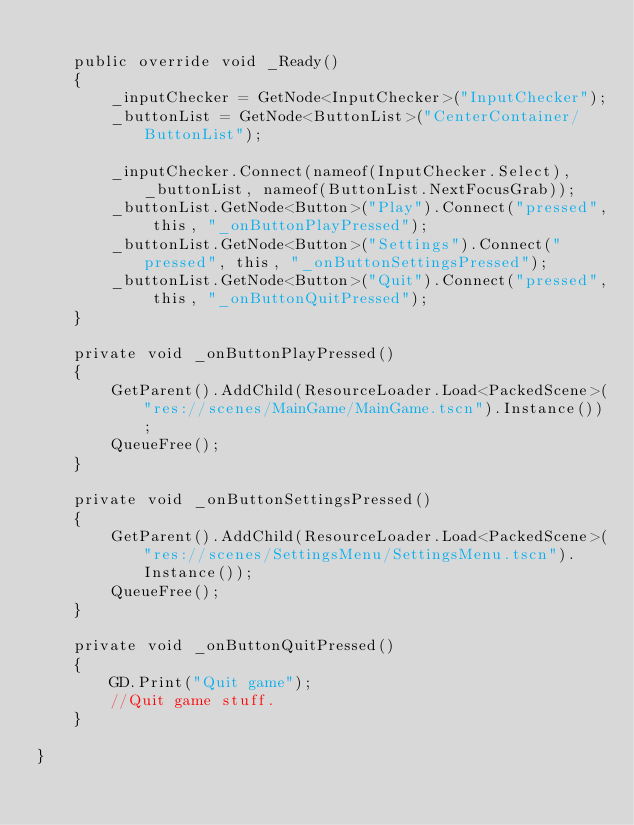<code> <loc_0><loc_0><loc_500><loc_500><_C#_>
	public override void _Ready()
	{
		_inputChecker = GetNode<InputChecker>("InputChecker");
		_buttonList = GetNode<ButtonList>("CenterContainer/ButtonList");

		_inputChecker.Connect(nameof(InputChecker.Select), _buttonList, nameof(ButtonList.NextFocusGrab));
		_buttonList.GetNode<Button>("Play").Connect("pressed", this, "_onButtonPlayPressed");
		_buttonList.GetNode<Button>("Settings").Connect("pressed", this, "_onButtonSettingsPressed");
		_buttonList.GetNode<Button>("Quit").Connect("pressed", this, "_onButtonQuitPressed");
	}

	private void _onButtonPlayPressed()
	{
		GetParent().AddChild(ResourceLoader.Load<PackedScene>("res://scenes/MainGame/MainGame.tscn").Instance());
		QueueFree();
	}

	private void _onButtonSettingsPressed()
	{
		GetParent().AddChild(ResourceLoader.Load<PackedScene>("res://scenes/SettingsMenu/SettingsMenu.tscn").Instance());
		QueueFree();
	}

	private void _onButtonQuitPressed()
	{
		GD.Print("Quit game");
		//Quit game stuff.
	}

}
</code> 